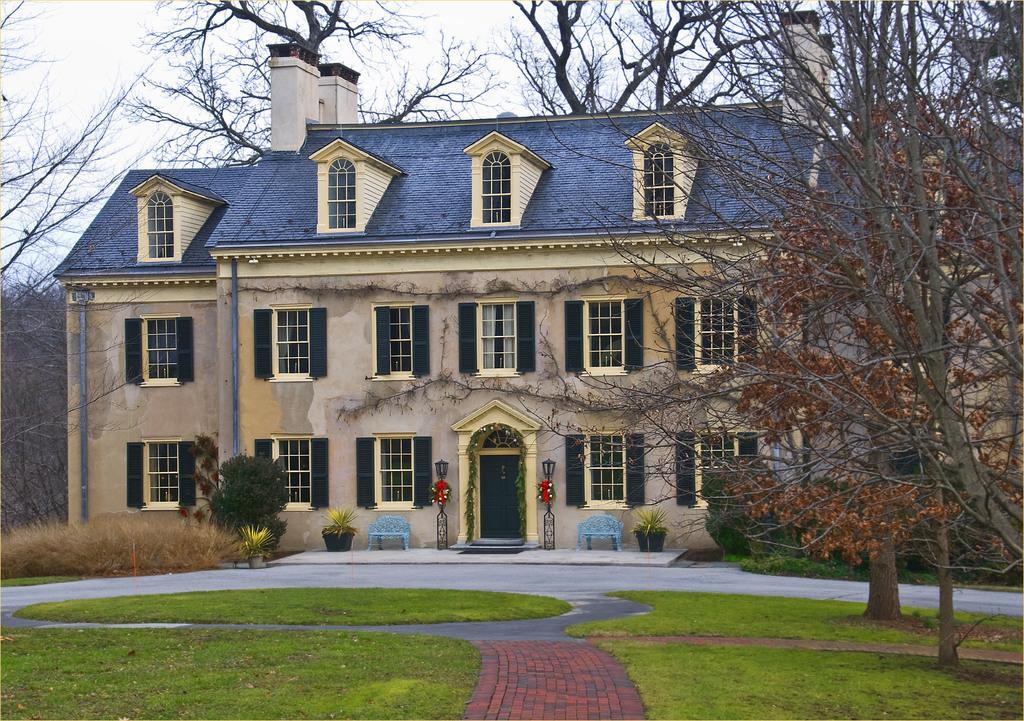Could you give a brief overview of what you see in this image? In this image I can see grass, plants in pots, trees, a building, number of windows and few blue colored benches. 